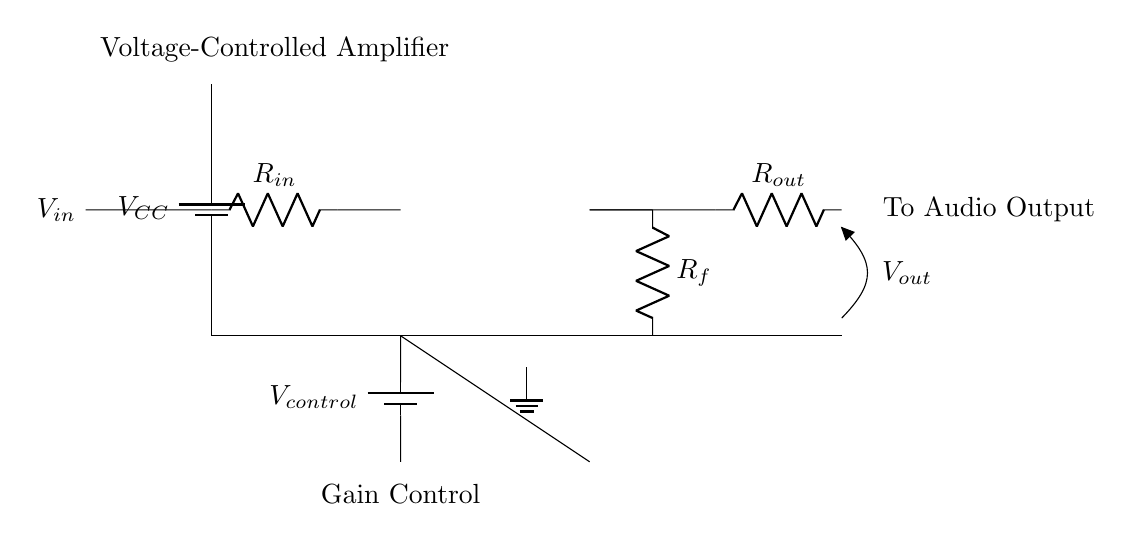What is the type of amplifier shown in the circuit? The circuit diagram depicts a voltage-controlled amplifier, which is characterized by its usage of a control voltage to adjust the gain of the output signal based on the input.
Answer: voltage-controlled amplifier What is the input signal labeled as? In the circuit diagram, the input signal is labeled as V-in, which is the voltage that will be amplified by the operational amplifier.
Answer: V-in What component is used for feedback in this circuit? The feedback in this circuit is provided by the resistor labeled as R-f. This resistor allows a portion of the output voltage to be fed back to the input, which determines the gain of the amplifier.
Answer: R-f What is the purpose of the control voltage in this circuit? The control voltage, labeled as V-control, adjusts the gain of the amplifier, allowing for variable output levels depending on the needs of the patient monitoring system.
Answer: adjust gain What is the output voltage labeled as? The output voltage in the circuit is indicated as V-out, representing the amplified signal that will be sent to the audio output.
Answer: V-out How does changing R-f affect the circuit's gain? Changing R-f modifies the feedback path of the amplifier, which directly influences the gain equation of the operational amplifier, allowing for higher or lower output based on the desired gain configuration.
Answer: affects gain What are the connections that ground the circuit? The circuit is grounded through the connections at the negative terminal of the battery and the lower part of the circuit schematic, which are both connected to the ground symbol.
Answer: ground connections 